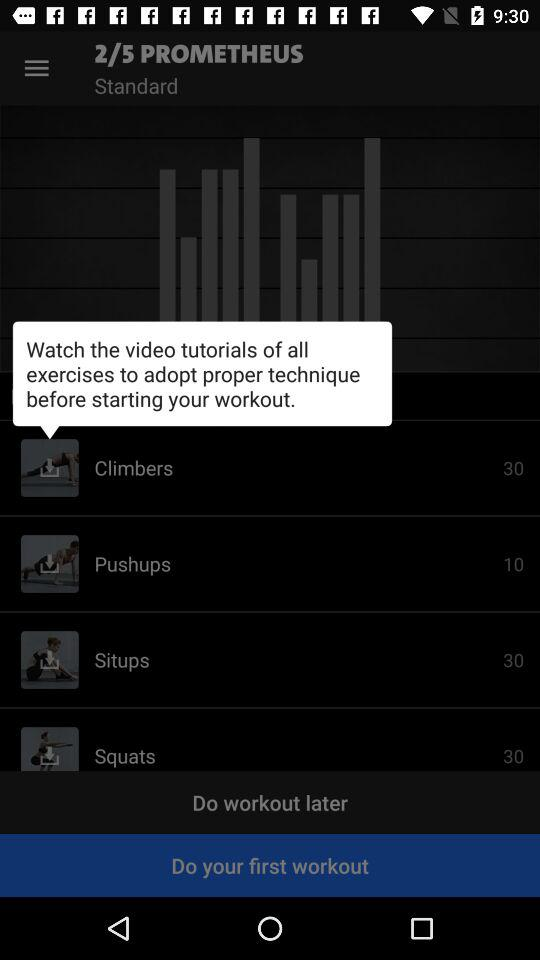How many exercises are there in total?
Answer the question using a single word or phrase. 4 